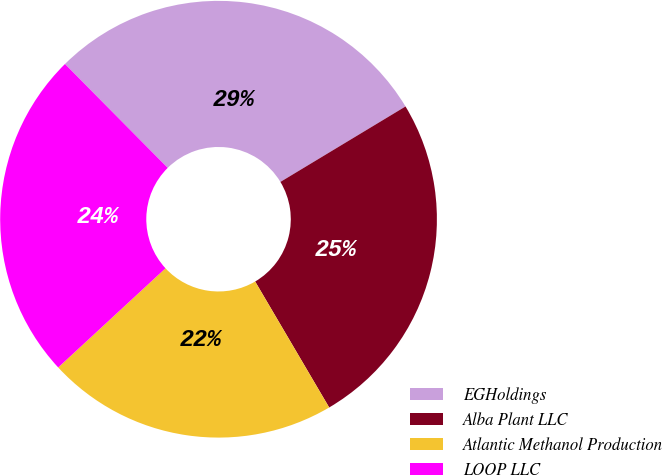<chart> <loc_0><loc_0><loc_500><loc_500><pie_chart><fcel>EGHoldings<fcel>Alba Plant LLC<fcel>Atlantic Methanol Production<fcel>LOOP LLC<nl><fcel>28.78%<fcel>25.18%<fcel>21.58%<fcel>24.46%<nl></chart> 